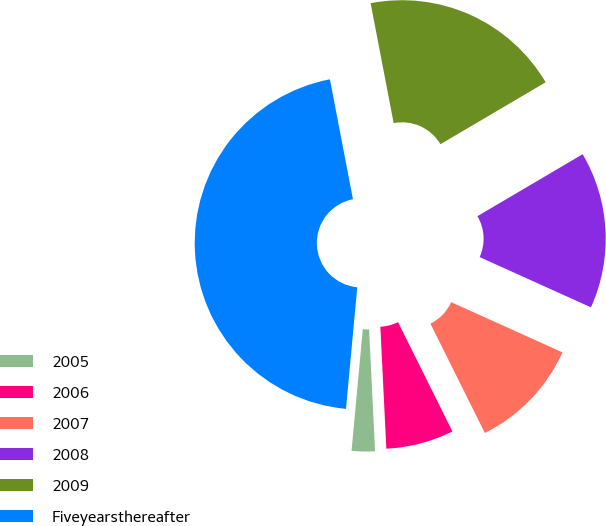<chart> <loc_0><loc_0><loc_500><loc_500><pie_chart><fcel>2005<fcel>2006<fcel>2007<fcel>2008<fcel>2009<fcel>Fiveyearsthereafter<nl><fcel>2.25%<fcel>6.57%<fcel>10.9%<fcel>15.22%<fcel>19.55%<fcel>45.51%<nl></chart> 